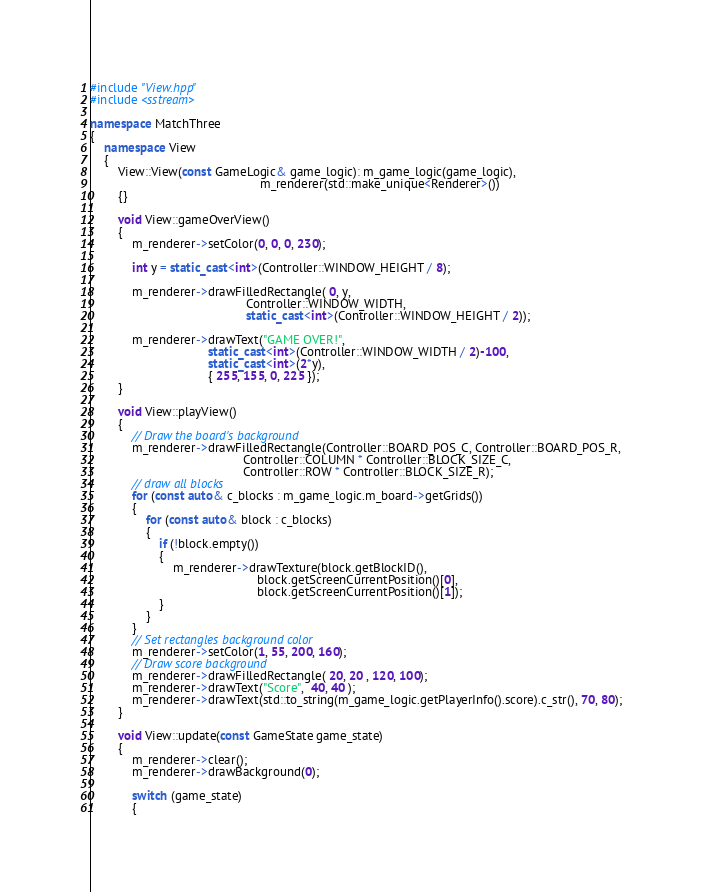Convert code to text. <code><loc_0><loc_0><loc_500><loc_500><_C++_>#include "View.hpp"
#include <sstream>

namespace MatchThree 
{
    namespace View
    {
        View::View(const GameLogic& game_logic): m_game_logic(game_logic),
                                                 m_renderer(std::make_unique<Renderer>())
        {}

        void View::gameOverView()
        {
            m_renderer->setColor(0, 0, 0, 230);

            int y = static_cast<int>(Controller::WINDOW_HEIGHT / 8);

            m_renderer->drawFilledRectangle( 0, y,
                                             Controller::WINDOW_WIDTH,
                                             static_cast<int>(Controller::WINDOW_HEIGHT / 2));

            m_renderer->drawText("GAME OVER!", 
                                  static_cast<int>(Controller::WINDOW_WIDTH / 2)-100,
                                  static_cast<int>(2*y),
                                  { 255, 155, 0, 225 });
        }

        void View::playView()
        {
            // Draw the board's background
            m_renderer->drawFilledRectangle(Controller::BOARD_POS_C, Controller::BOARD_POS_R,
                                            Controller::COLUMN * Controller::BLOCK_SIZE_C,
                                            Controller::ROW * Controller::BLOCK_SIZE_R);
            // draw all blocks
            for (const auto& c_blocks : m_game_logic.m_board->getGrids())
            {
                for (const auto& block : c_blocks)
                {
                    if (!block.empty())
                    {
                        m_renderer->drawTexture(block.getBlockID(),
                                                block.getScreenCurrentPosition()[0],
                                                block.getScreenCurrentPosition()[1]);
                    }
                }
            }
            // Set rectangles background color
            m_renderer->setColor(1, 55, 200, 160);
            // Draw score background
            m_renderer->drawFilledRectangle( 20, 20 , 120, 100);
            m_renderer->drawText("Score",  40, 40 );
            m_renderer->drawText(std::to_string(m_game_logic.getPlayerInfo().score).c_str(), 70, 80);
        }

        void View::update(const GameState game_state)
        {
            m_renderer->clear();
            m_renderer->drawBackground(0);
            
            switch (game_state)
            {</code> 